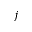Convert formula to latex. <formula><loc_0><loc_0><loc_500><loc_500>j</formula> 